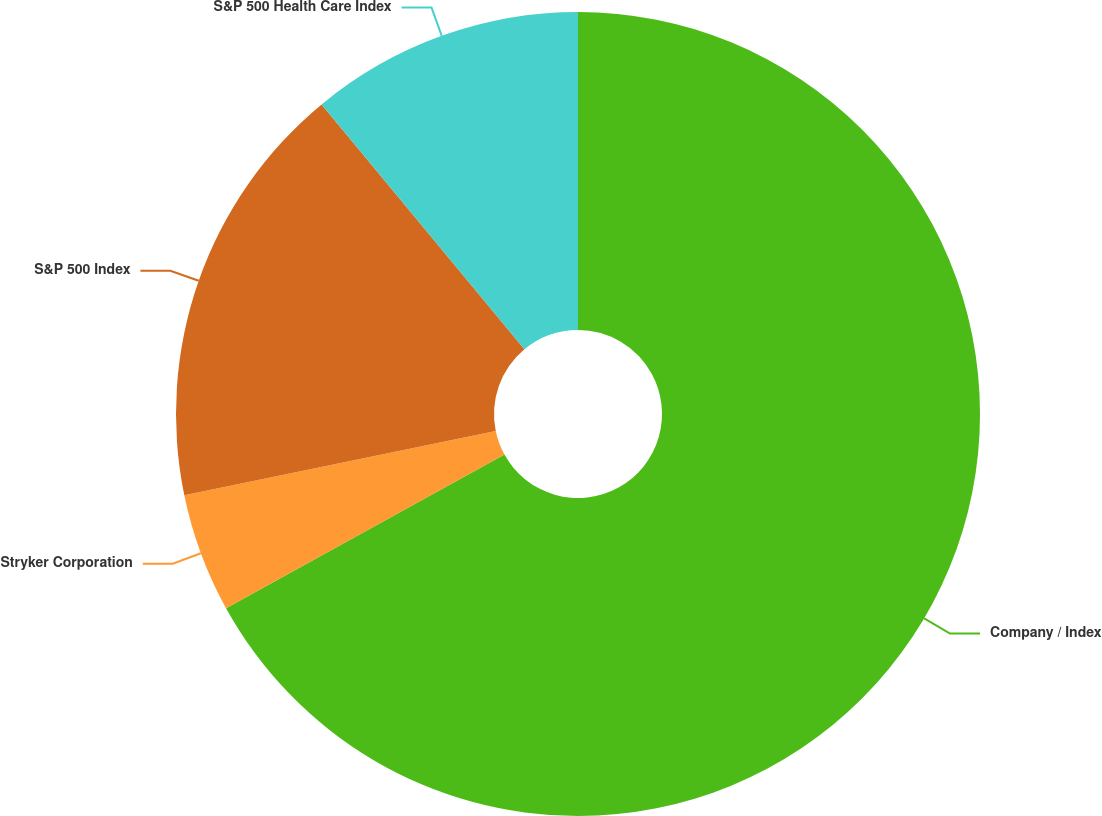Convert chart to OTSL. <chart><loc_0><loc_0><loc_500><loc_500><pie_chart><fcel>Company / Index<fcel>Stryker Corporation<fcel>S&P 500 Index<fcel>S&P 500 Health Care Index<nl><fcel>66.98%<fcel>4.79%<fcel>17.23%<fcel>11.01%<nl></chart> 